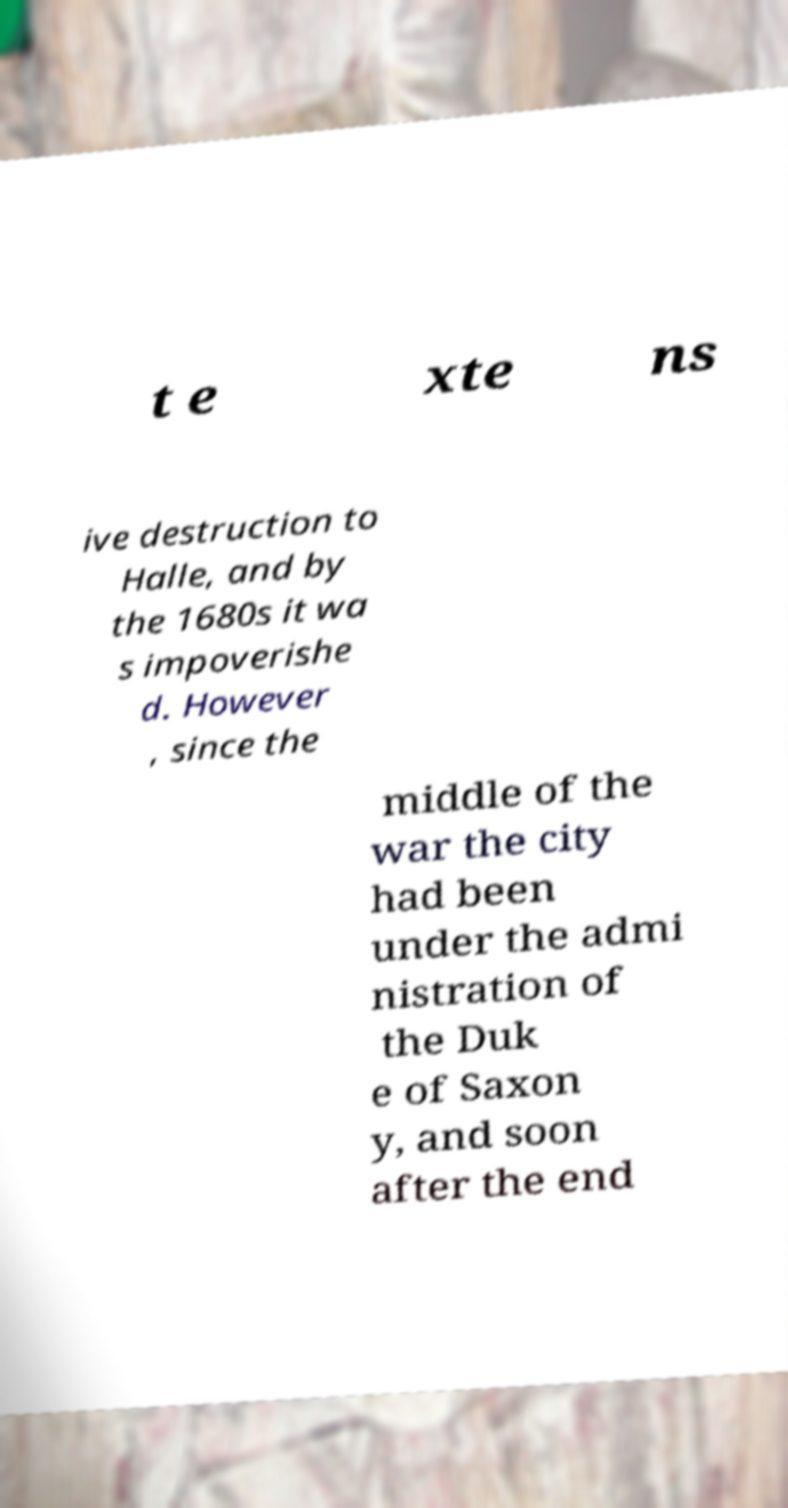Please read and relay the text visible in this image. What does it say? t e xte ns ive destruction to Halle, and by the 1680s it wa s impoverishe d. However , since the middle of the war the city had been under the admi nistration of the Duk e of Saxon y, and soon after the end 